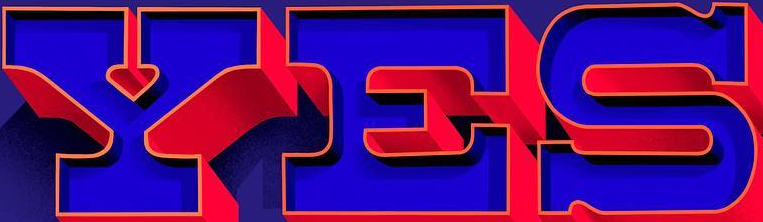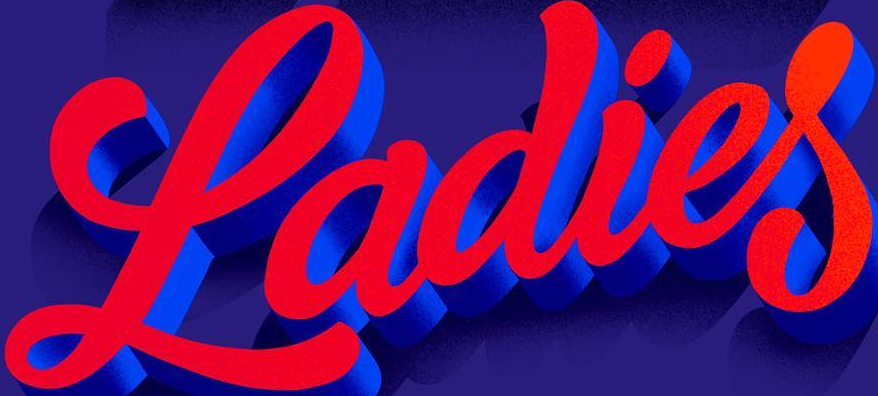Identify the words shown in these images in order, separated by a semicolon. YES; Ladies 